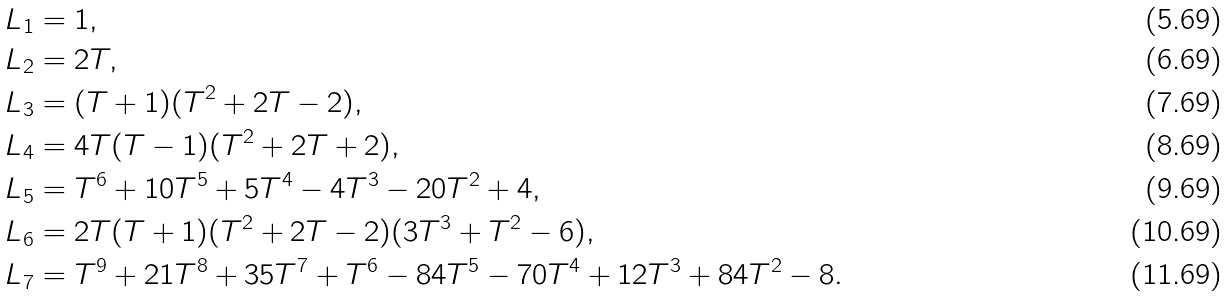Convert formula to latex. <formula><loc_0><loc_0><loc_500><loc_500>L _ { 1 } & = 1 , \\ L _ { 2 } & = 2 T , \\ L _ { 3 } & = ( T + 1 ) ( T ^ { 2 } + 2 T - 2 ) , \\ L _ { 4 } & = 4 T ( T - 1 ) ( T ^ { 2 } + 2 T + 2 ) , \\ L _ { 5 } & = T ^ { 6 } + 1 0 T ^ { 5 } + 5 T ^ { 4 } - 4 T ^ { 3 } - 2 0 T ^ { 2 } + 4 , \\ L _ { 6 } & = 2 T ( T + 1 ) ( T ^ { 2 } + 2 T - 2 ) ( 3 T ^ { 3 } + T ^ { 2 } - 6 ) , \\ L _ { 7 } & = T ^ { 9 } + 2 1 T ^ { 8 } + 3 5 T ^ { 7 } + T ^ { 6 } - 8 4 T ^ { 5 } - 7 0 T ^ { 4 } + 1 2 T ^ { 3 } + 8 4 T ^ { 2 } - 8 .</formula> 